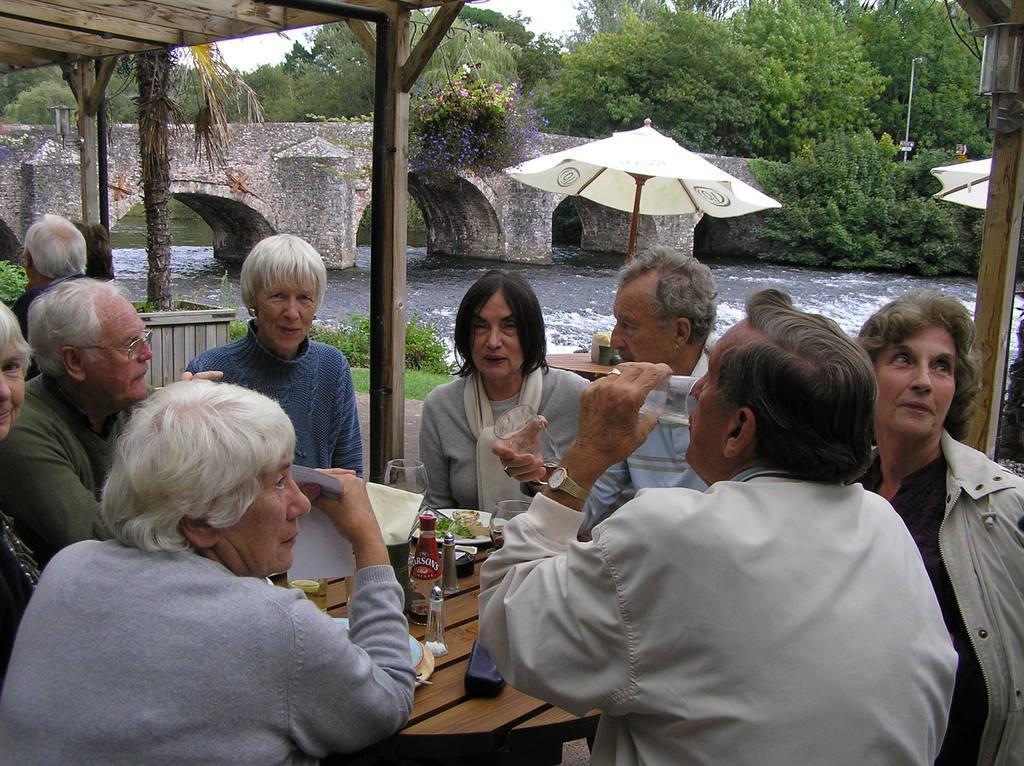Please provide a concise description of this image. In this image I see number of people and all of them are sitting on chairs and I see a table in front of them on which there are many things. I also see that these 2 men are holding glasses and this woman is holding a paper. In the background I see the grass, plants, umbrellas, a bridge, water and the trees. 